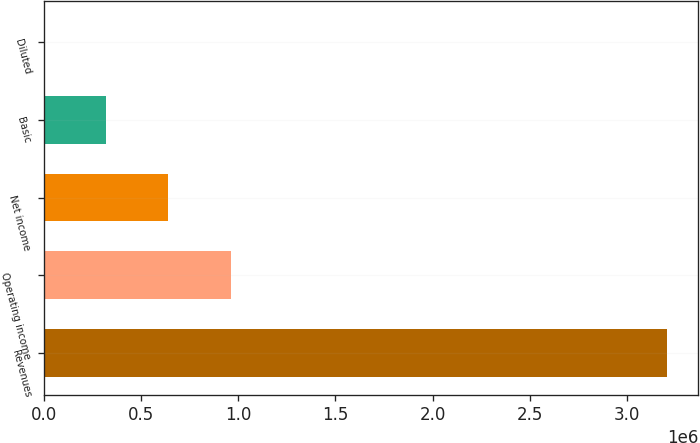Convert chart to OTSL. <chart><loc_0><loc_0><loc_500><loc_500><bar_chart><fcel>Revenues<fcel>Operating income<fcel>Net income<fcel>Basic<fcel>Diluted<nl><fcel>3.20458e+06<fcel>961374<fcel>640916<fcel>320458<fcel>0.59<nl></chart> 